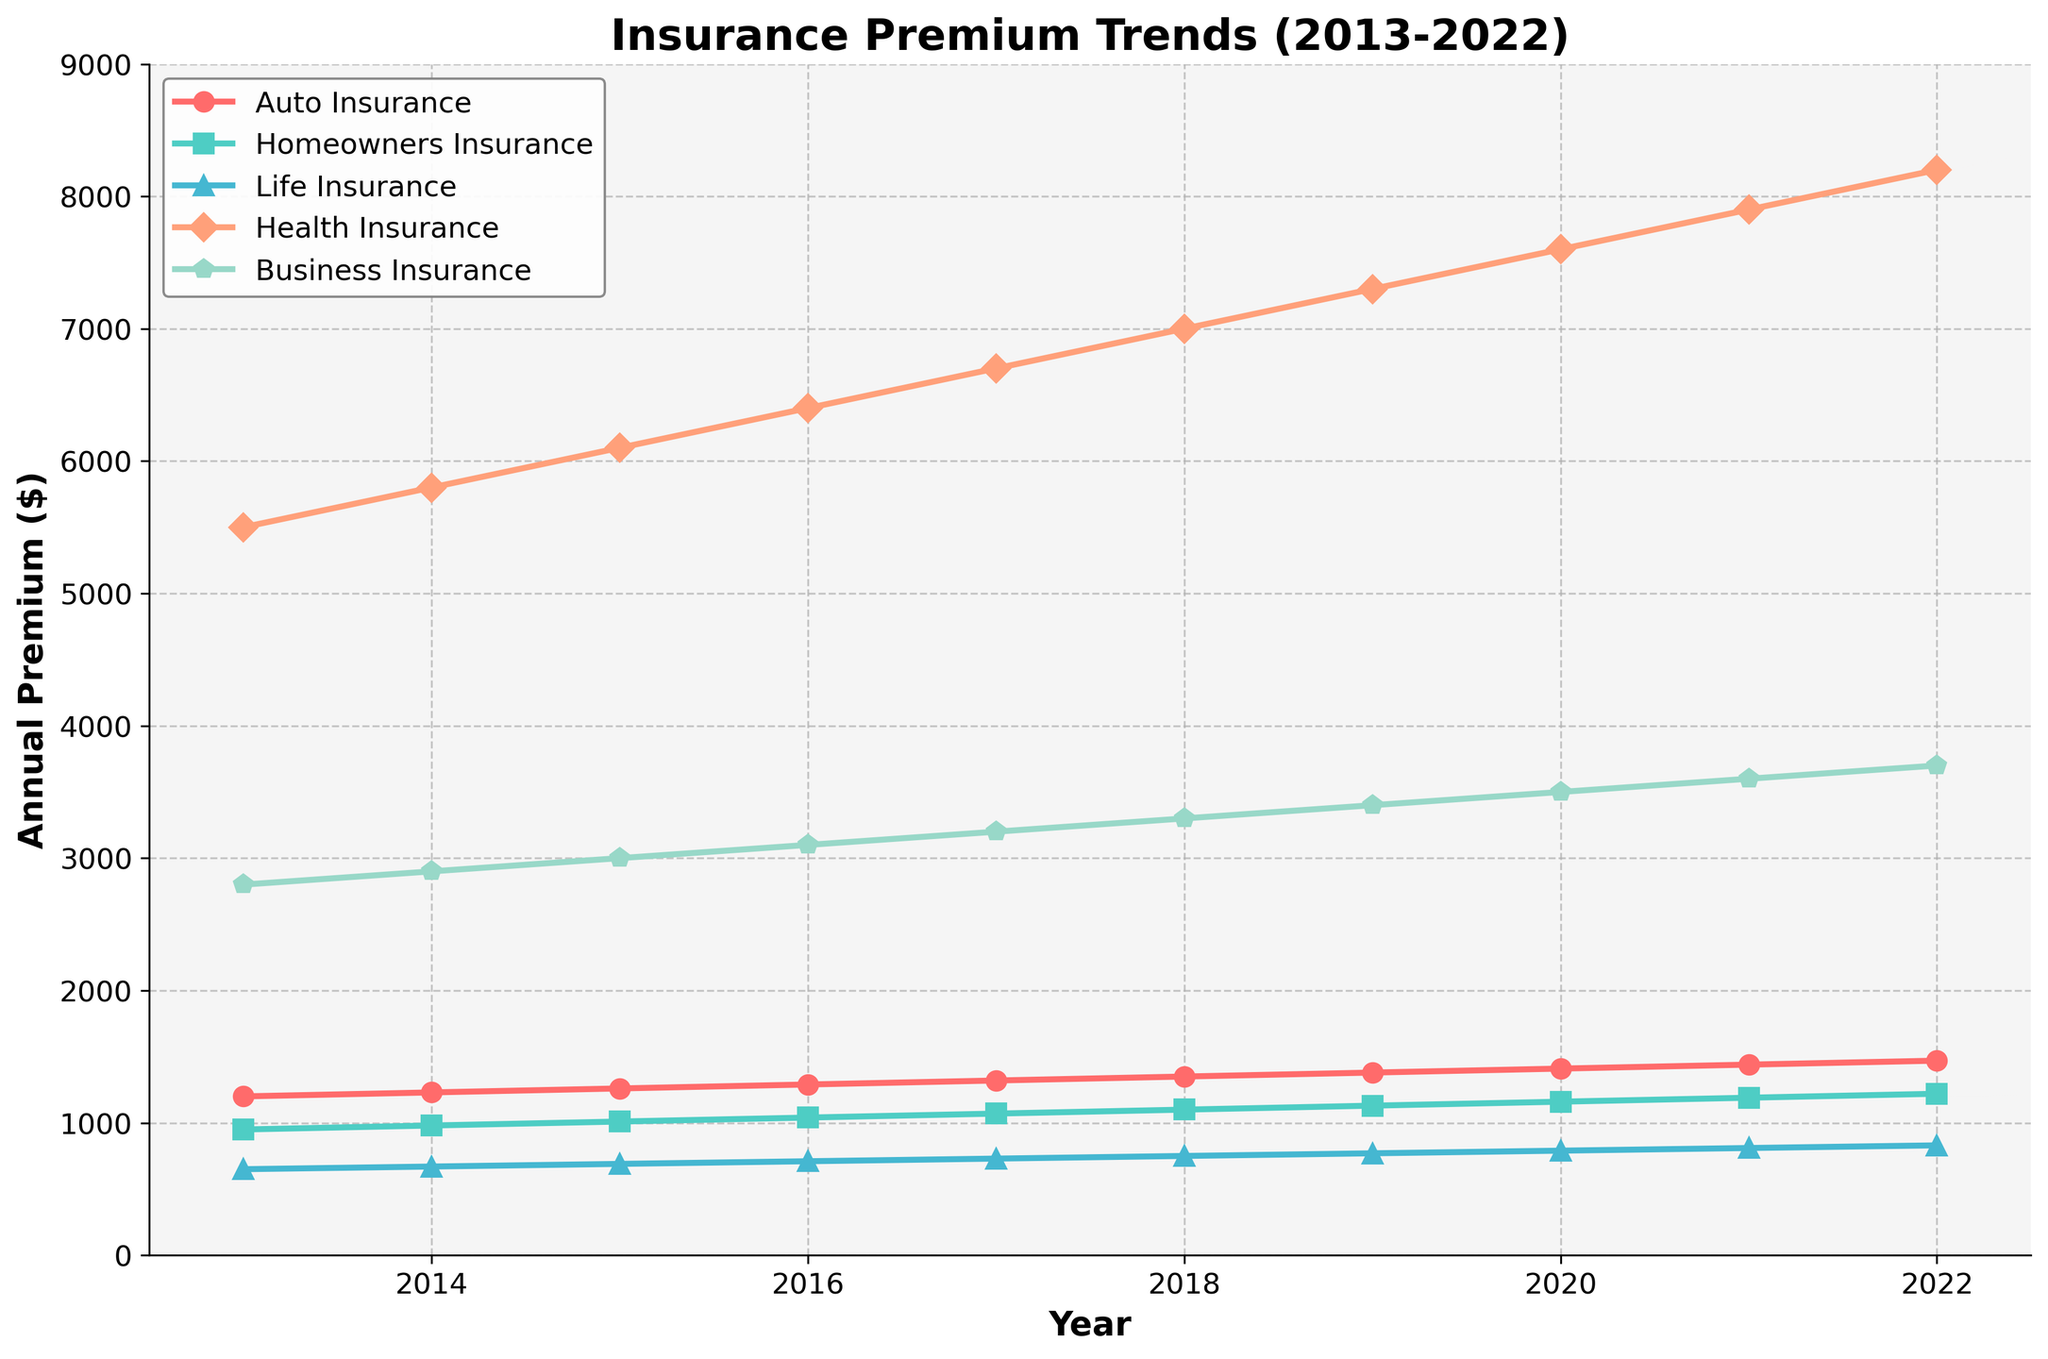How has the Auto Insurance premium changed from 2013 to 2022? Start with the value in 2013, which is $1200, and compare it to the value in 2022, which is $1470. The difference is $1470 - $1200 = $270.
Answer: $270 increase Which insurance type had the highest annual premium in 2017? In 2017, the annual premiums are Auto: $1320, Homeowners: $1070, Life: $730, Health: $6700, Business: $3200. The highest value is $6700 for Health Insurance.
Answer: Health Insurance What is the average annual premium for Life Insurance over the decade? Sum the premiums for Life Insurance from 2013 to 2022: 650 + 670 + 690 + 710 + 730 + 750 + 770 + 790 + 810 + 830 = 7400. The average is 7400 / 10 = 740.
Answer: $740 Did Health Insurance or Business Insurance have a steeper increase from 2013 to 2022? Health Insurance increase: $8200 - $5500 = $2700. Business Insurance increase: $3700 - $2800 = $900. Health Insurance had a steeper increase.
Answer: Health Insurance What was the rate of increase for Homeowners Insurance premiums from 2018 to 2022? Homeowners Insurance premium in 2018 was $1100, and in 2022 it was $1220. The rate of increase is (1220 - 1100) / 1100 = 0.1091 or 10.91%.
Answer: 10.91% Which insurance type had the smallest annual premium in 2020? In 2020, the premiums are Auto: $1410, Homeowners: $1160, Life: $790, Health: $7600, Business: $3500. The smallest value is $790 for Life Insurance.
Answer: Life Insurance How much did the average premium for Business Insurance increase per year from 2013 to 2022? Business Insurance premiums from 2013 to 2022 are: 2800, 2900, 3000, 3100, 3200, 3300, 3400, 3500, 3600, 3700. The total increase is $3700 - $2800 = $900. There are 9 years between 2013 and 2022. The yearly increase on average is $900 / 9 = $100.
Answer: $100 per year What is the average premium for all insurance types in 2019? Sum the premiums for all insurance types in 2019: $1380 + $1130 + $770 + $7300 + $3400 = $13980. There are 5 types, so the average is $13980 / 5 = $2796.
Answer: $2796 Which insurance type had the lowest increase in premiums over the decade? Calculate the increase for each: Auto: $1470 - $1200 = $270, Homeowners: $1220 - $950 = $270, Life: $830 - $650 = $180, Health: $8200 - $5500 = $2700, Business: $3700 - $2800 = $900. Life Insurance had the lowest increase of $180.
Answer: Life Insurance Are Auto Insurance premiums higher than Homeowners Insurance premiums in 2020? Auto Insurance premium in 2020 is $1410, whereas Homeowners Insurance premium is $1160. $1410 is higher than $1160.
Answer: Yes 